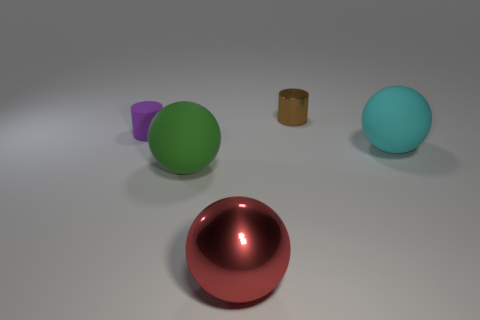Does the green thing have the same shape as the rubber object that is behind the big cyan ball?
Offer a terse response. No. The cylinder that is made of the same material as the big red object is what size?
Your answer should be compact. Small. The thing that is in front of the large rubber object left of the large matte sphere behind the large green rubber object is made of what material?
Provide a succinct answer. Metal. How many metal objects are brown objects or green balls?
Your answer should be compact. 1. What number of things are either green rubber objects or tiny cylinders that are on the left side of the big green matte thing?
Make the answer very short. 2. There is a cylinder in front of the shiny cylinder; is its size the same as the tiny metal object?
Ensure brevity in your answer.  Yes. How many other objects are the same shape as the large cyan object?
Ensure brevity in your answer.  2. How many purple objects are tiny things or small shiny things?
Offer a very short reply. 1. What is the shape of the big green object that is made of the same material as the large cyan object?
Ensure brevity in your answer.  Sphere. The matte thing that is both to the left of the large red sphere and behind the green rubber sphere is what color?
Your answer should be compact. Purple. 